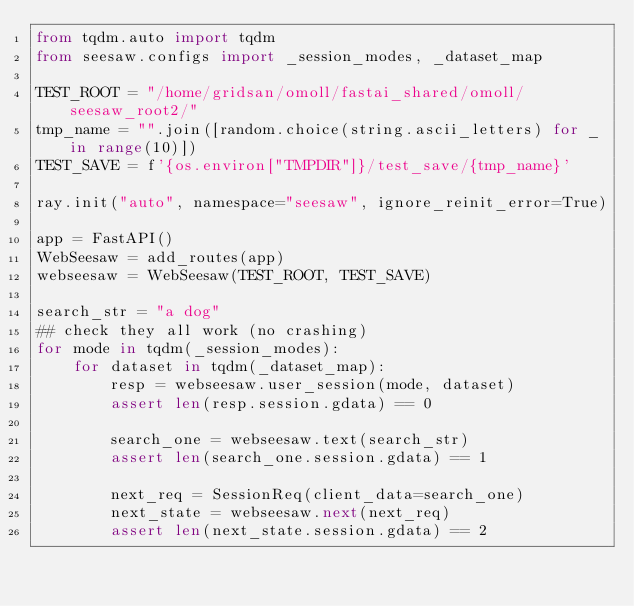Convert code to text. <code><loc_0><loc_0><loc_500><loc_500><_Python_>from tqdm.auto import tqdm
from seesaw.configs import _session_modes, _dataset_map

TEST_ROOT = "/home/gridsan/omoll/fastai_shared/omoll/seesaw_root2/"
tmp_name = "".join([random.choice(string.ascii_letters) for _ in range(10)])
TEST_SAVE = f'{os.environ["TMPDIR"]}/test_save/{tmp_name}'

ray.init("auto", namespace="seesaw", ignore_reinit_error=True)

app = FastAPI()
WebSeesaw = add_routes(app)
webseesaw = WebSeesaw(TEST_ROOT, TEST_SAVE)

search_str = "a dog"
## check they all work (no crashing)
for mode in tqdm(_session_modes):
    for dataset in tqdm(_dataset_map):
        resp = webseesaw.user_session(mode, dataset)
        assert len(resp.session.gdata) == 0

        search_one = webseesaw.text(search_str)
        assert len(search_one.session.gdata) == 1

        next_req = SessionReq(client_data=search_one)
        next_state = webseesaw.next(next_req)
        assert len(next_state.session.gdata) == 2
</code> 